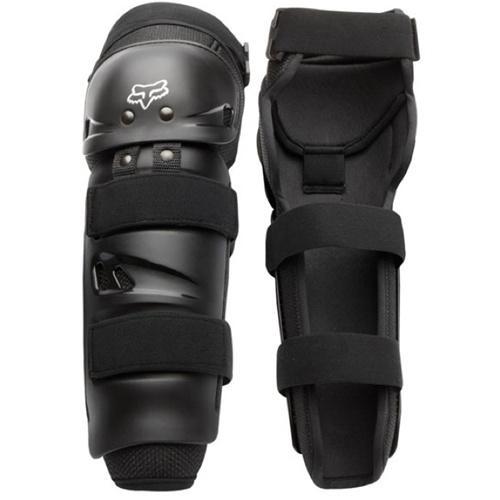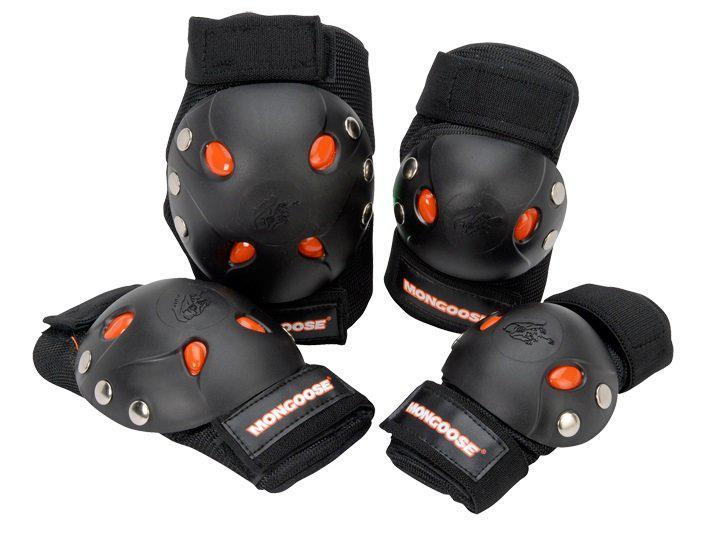The first image is the image on the left, the second image is the image on the right. Given the left and right images, does the statement "One pair of guards is incomplete." hold true? Answer yes or no. No. 